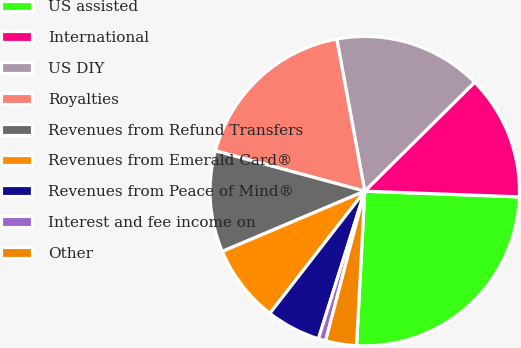Convert chart. <chart><loc_0><loc_0><loc_500><loc_500><pie_chart><fcel>US assisted<fcel>International<fcel>US DIY<fcel>Royalties<fcel>Revenues from Refund Transfers<fcel>Revenues from Emerald Card®<fcel>Revenues from Peace of Mind®<fcel>Interest and fee income on<fcel>Other<nl><fcel>25.26%<fcel>13.02%<fcel>15.46%<fcel>17.91%<fcel>10.57%<fcel>8.12%<fcel>5.67%<fcel>0.77%<fcel>3.22%<nl></chart> 